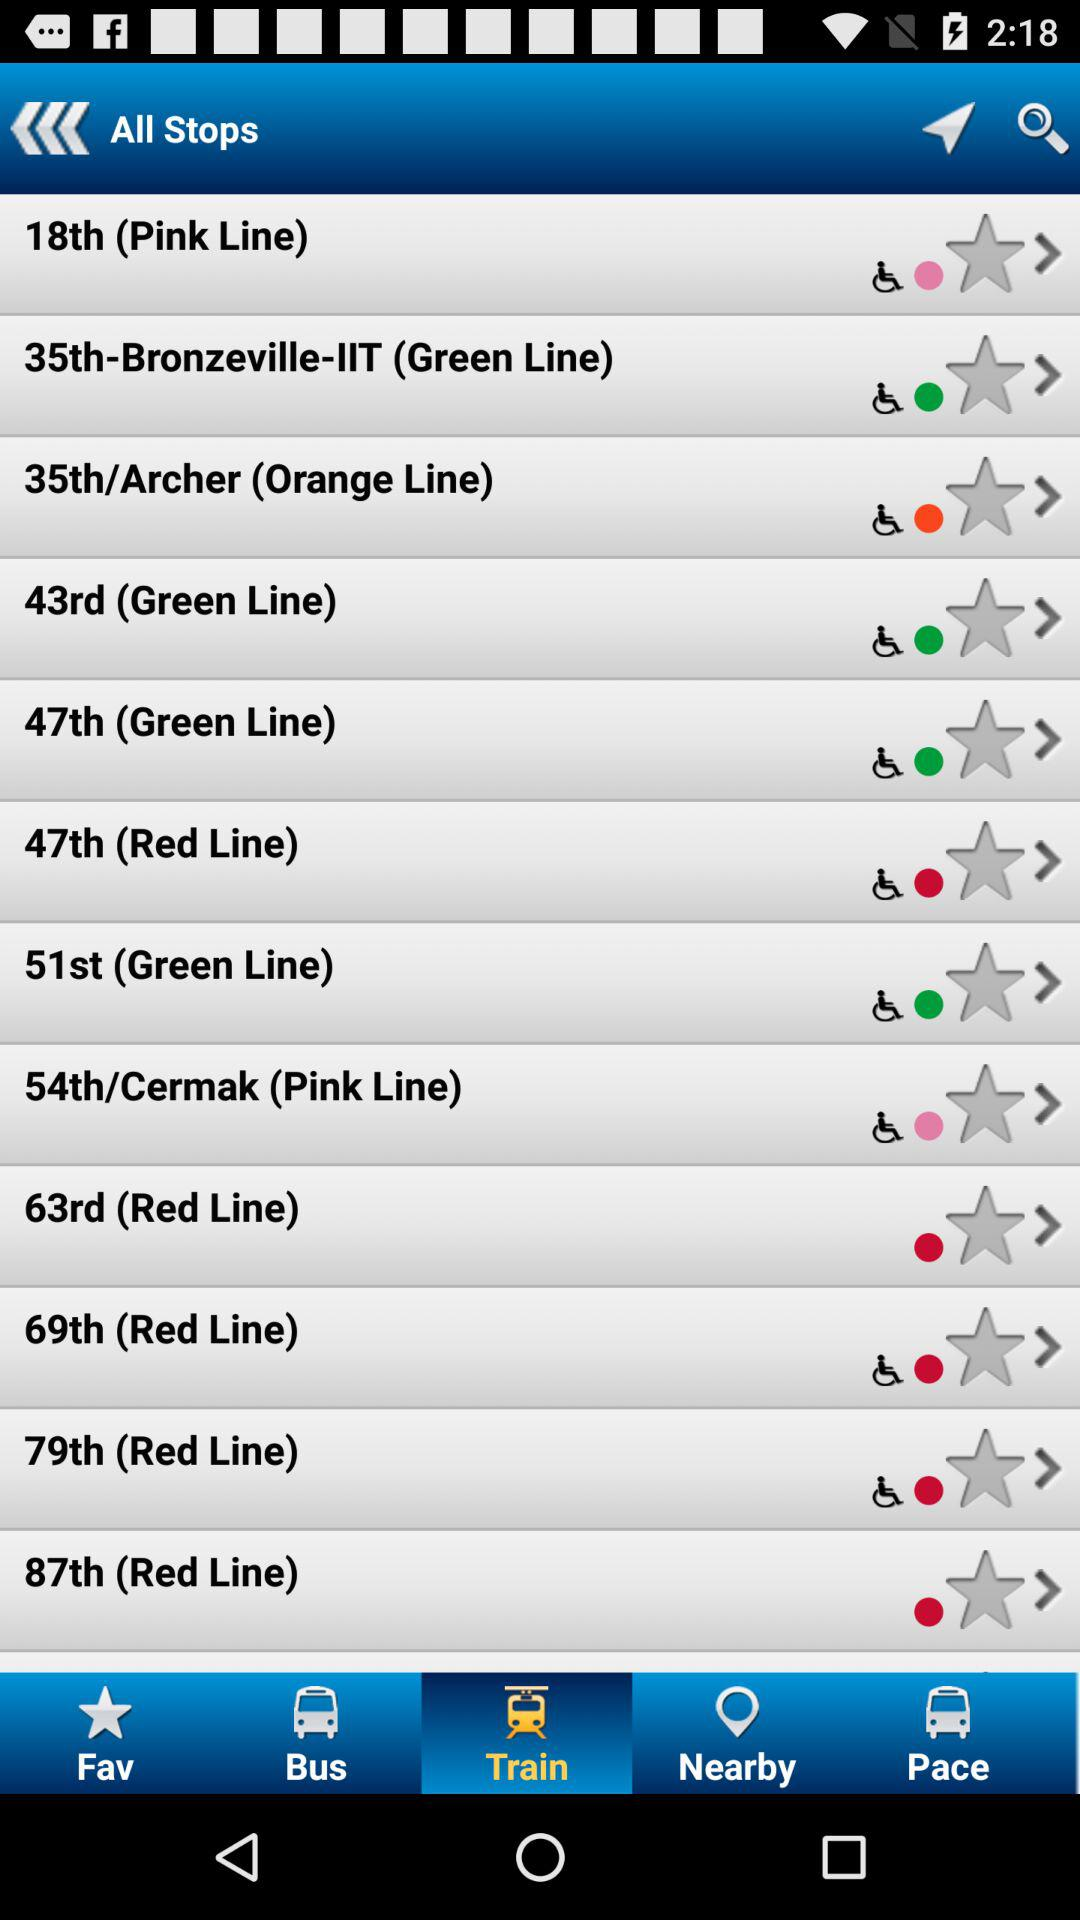Which tab is selected? The selected tab is "Train". 